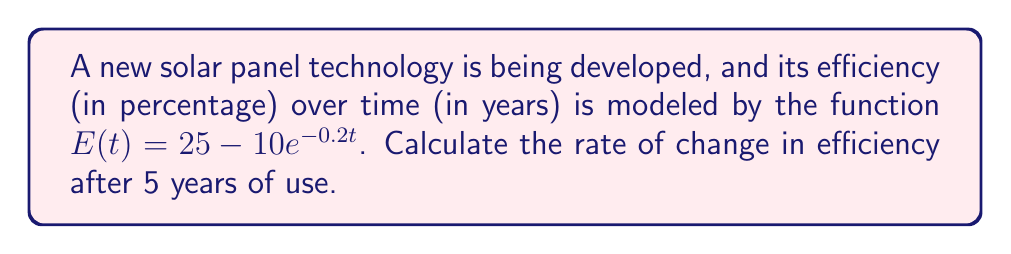Can you answer this question? To find the rate of change in efficiency after 5 years, we need to calculate the derivative of the given function and evaluate it at t = 5.

Step 1: Find the derivative of $E(t)$
$$\frac{d}{dt}E(t) = \frac{d}{dt}(25 - 10e^{-0.2t})$$
$$E'(t) = 0 - 10 \cdot \frac{d}{dt}(e^{-0.2t})$$
$$E'(t) = -10 \cdot (-0.2e^{-0.2t})$$
$$E'(t) = 2e^{-0.2t}$$

Step 2: Evaluate $E'(t)$ at t = 5
$$E'(5) = 2e^{-0.2(5)}$$
$$E'(5) = 2e^{-1}$$
$$E'(5) \approx 0.7358$$

Therefore, the rate of change in efficiency after 5 years is approximately 0.7358% per year.
Answer: $0.7358\%$ per year 